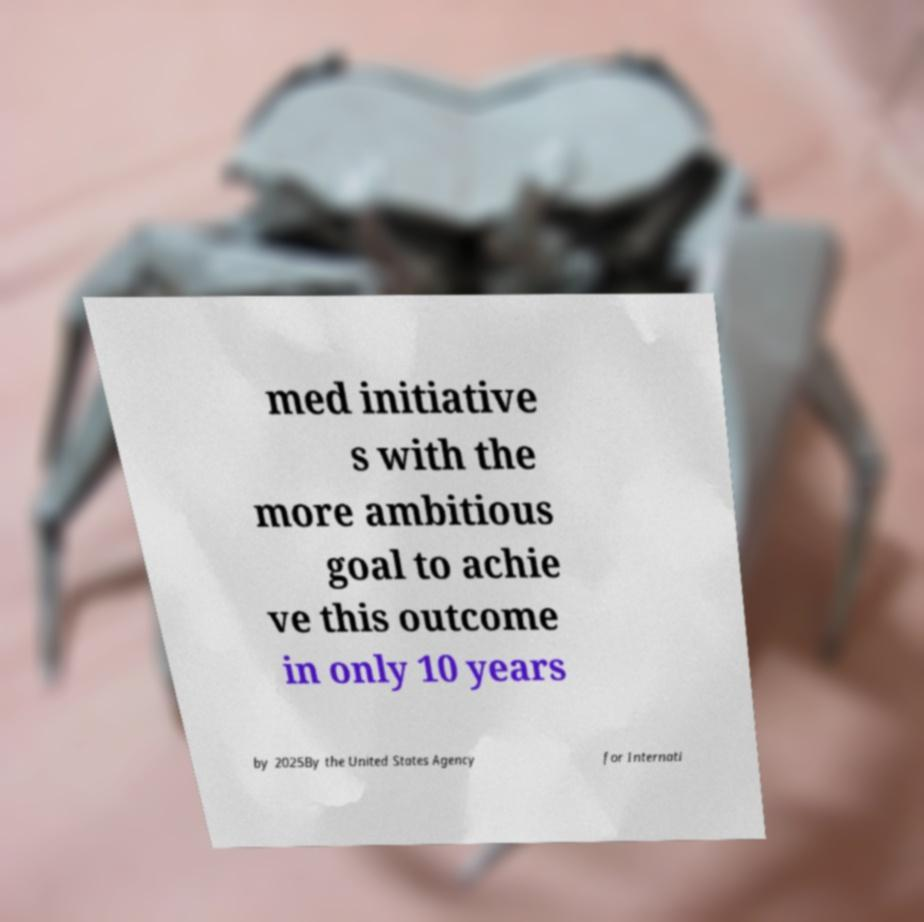Could you assist in decoding the text presented in this image and type it out clearly? med initiative s with the more ambitious goal to achie ve this outcome in only 10 years by 2025By the United States Agency for Internati 